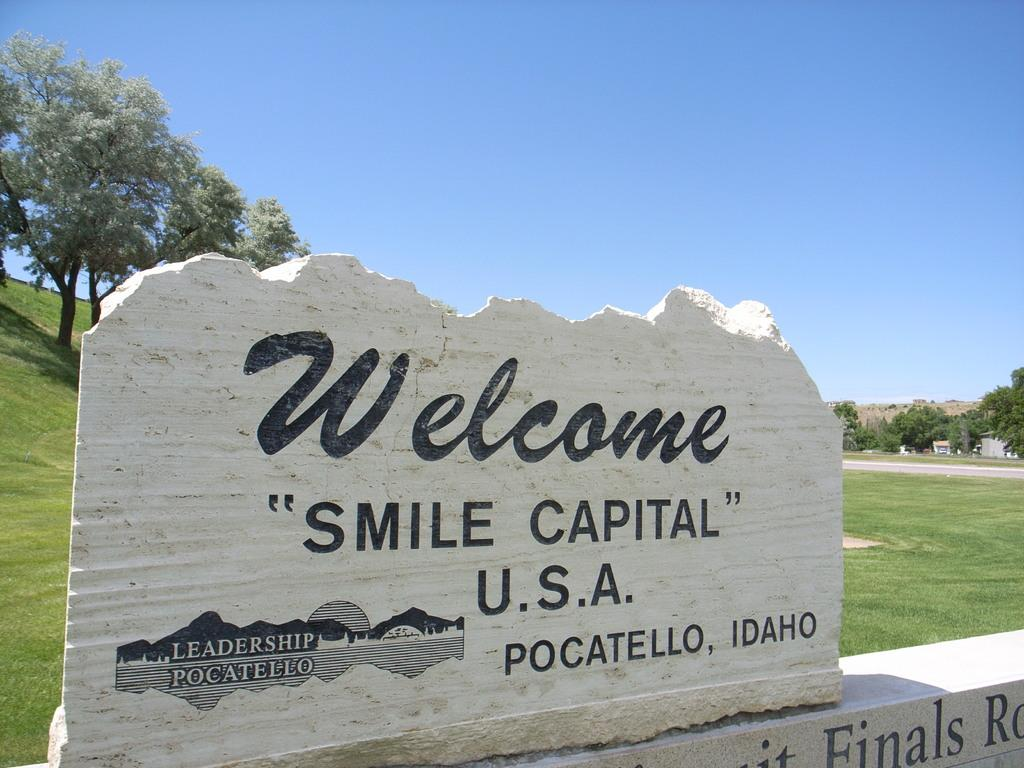Where was the image taken? The image was clicked outside. What can be seen written on the rocks in the image? There is writing on rocks in the image. What type of vegetation is visible on the left side of the image? There are trees on the left side of the image. What type of vegetation is visible on the right side of the image? There are trees on the right side of the image. What is visible at the top of the image? The sky is visible at the top of the image. What type of honey can be seen dripping from the trees in the image? There is no honey present in the image; it features writing on rocks and trees. 